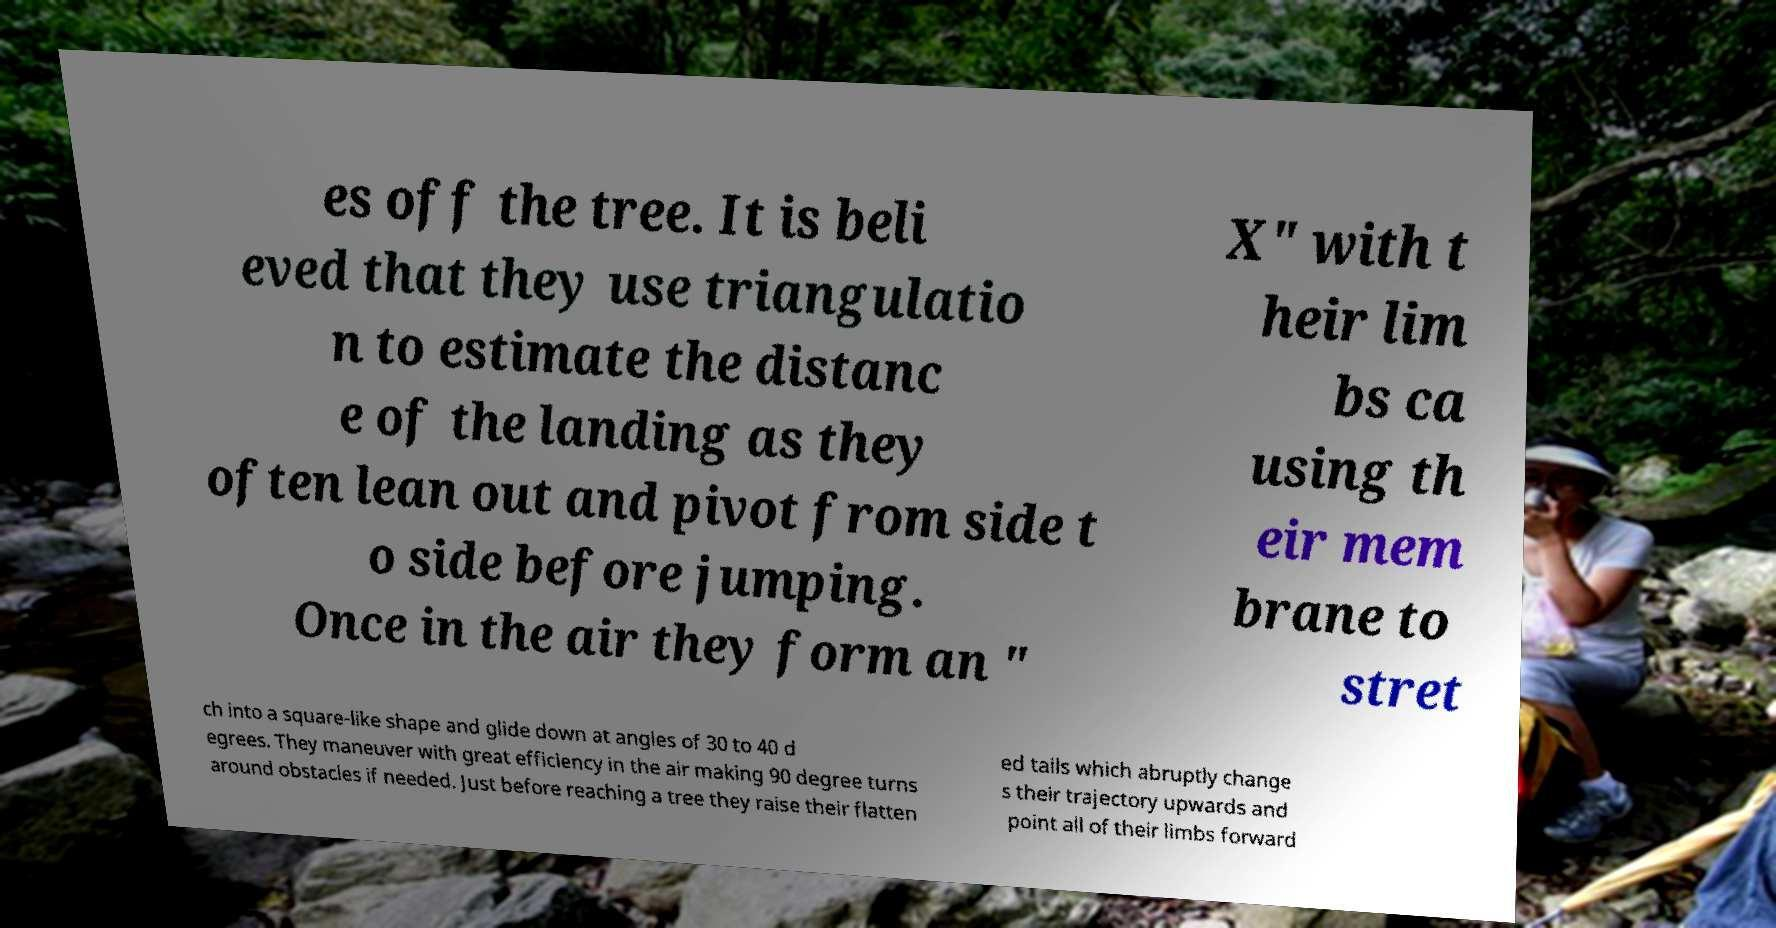Could you assist in decoding the text presented in this image and type it out clearly? es off the tree. It is beli eved that they use triangulatio n to estimate the distanc e of the landing as they often lean out and pivot from side t o side before jumping. Once in the air they form an " X" with t heir lim bs ca using th eir mem brane to stret ch into a square-like shape and glide down at angles of 30 to 40 d egrees. They maneuver with great efficiency in the air making 90 degree turns around obstacles if needed. Just before reaching a tree they raise their flatten ed tails which abruptly change s their trajectory upwards and point all of their limbs forward 